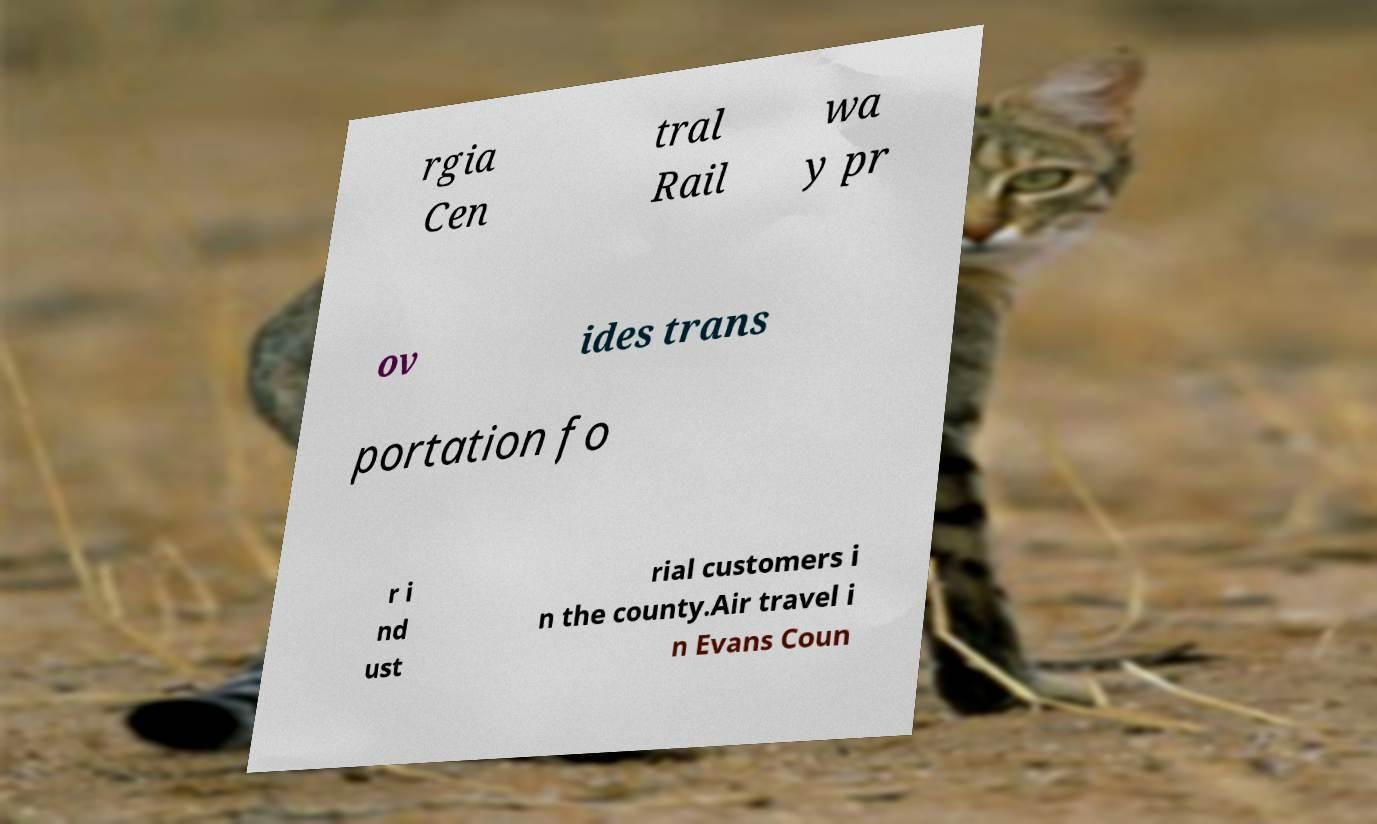Could you assist in decoding the text presented in this image and type it out clearly? rgia Cen tral Rail wa y pr ov ides trans portation fo r i nd ust rial customers i n the county.Air travel i n Evans Coun 